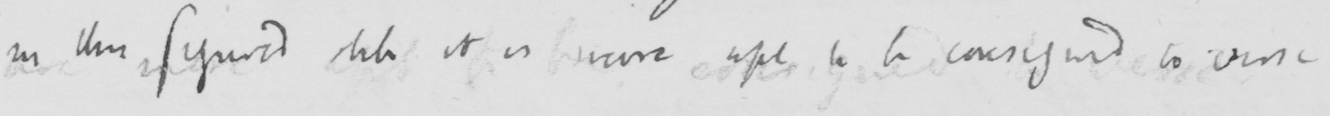Please transcribe the handwritten text in this image. in this figured stile it is more apt to be consigned to verse . 